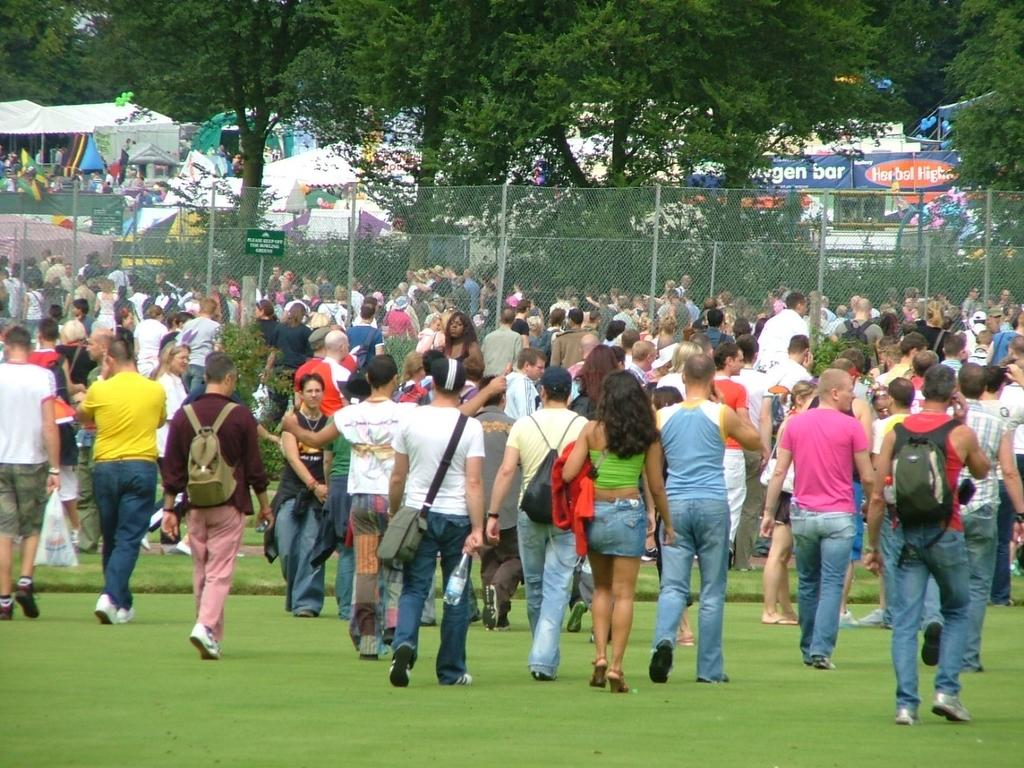What are the persons in the image wearing? The persons in the image are wearing different color dresses. Where are the persons located in the image? The persons are on the grass on the ground. What can be seen in the background of the image? There is a fencing, trees, and tents in the background of the image. What nation do the persons in the image belong to? The provided facts do not mention any specific nation, so it cannot be determined from the image. 